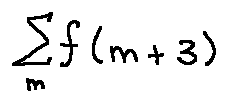Convert formula to latex. <formula><loc_0><loc_0><loc_500><loc_500>\sum \lim i t s _ { m } f ( m + 3 )</formula> 